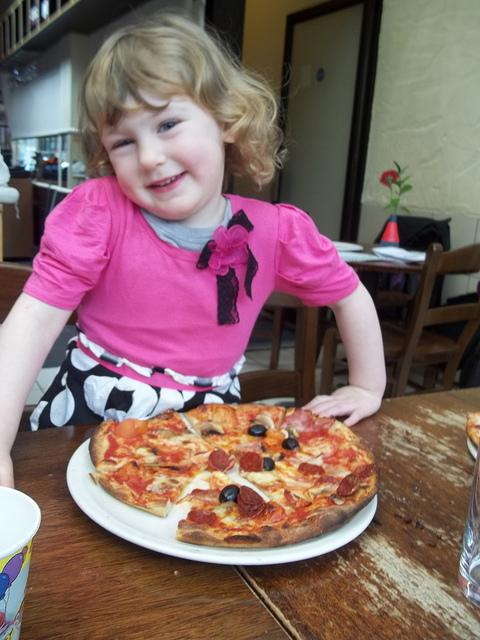What fruit might this person eat first? Please explain your reasoning. olives. The olives are on the pizza. 